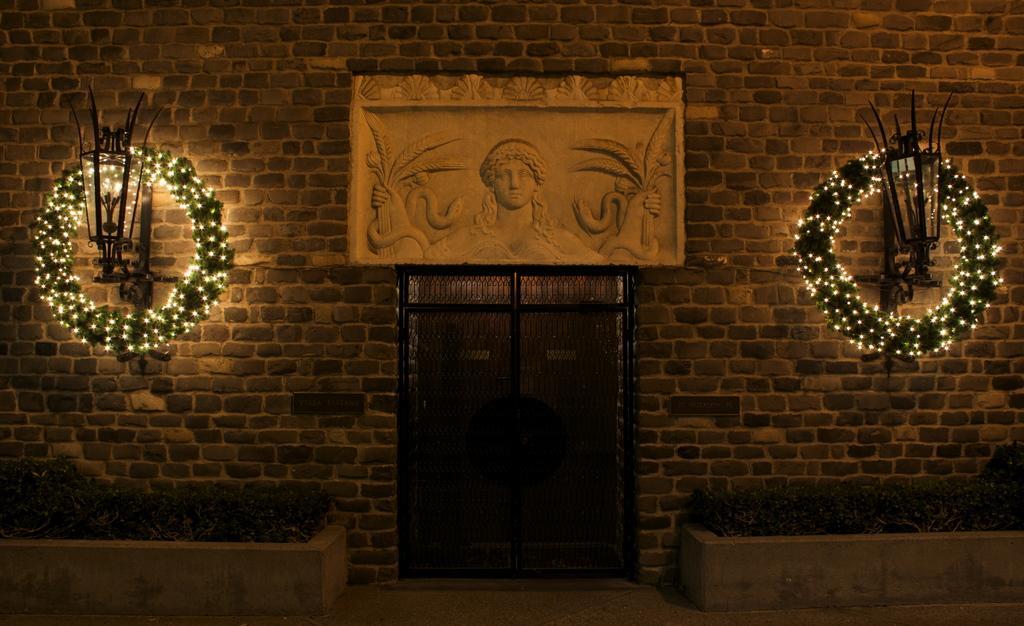Could you give a brief overview of what you see in this image? In this image I can see the grass. On the left and right side, I can see the wreath is decorated with the lights. In the middle I can see a door and a sculpture on the wall. 